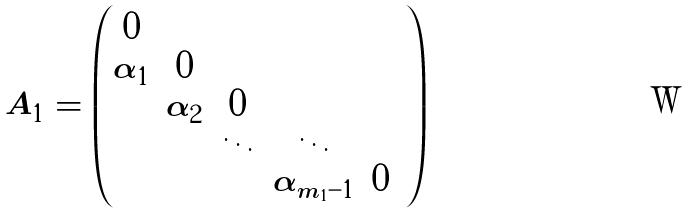<formula> <loc_0><loc_0><loc_500><loc_500>A _ { 1 } = \begin{pmatrix} 0 & & & & & \\ \alpha _ { 1 } & 0 & & & & \\ & \alpha _ { 2 } & 0 & & \\ & & \ddots & \ddots & & \\ & & & \alpha _ { m _ { 1 } - 1 } & 0 & \end{pmatrix}</formula> 